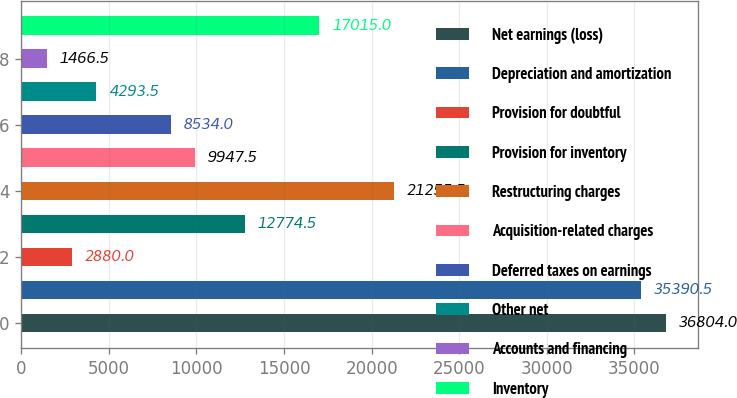Convert chart. <chart><loc_0><loc_0><loc_500><loc_500><bar_chart><fcel>Net earnings (loss)<fcel>Depreciation and amortization<fcel>Provision for doubtful<fcel>Provision for inventory<fcel>Restructuring charges<fcel>Acquisition-related charges<fcel>Deferred taxes on earnings<fcel>Other net<fcel>Accounts and financing<fcel>Inventory<nl><fcel>36804<fcel>35390.5<fcel>2880<fcel>12774.5<fcel>21255.5<fcel>9947.5<fcel>8534<fcel>4293.5<fcel>1466.5<fcel>17015<nl></chart> 